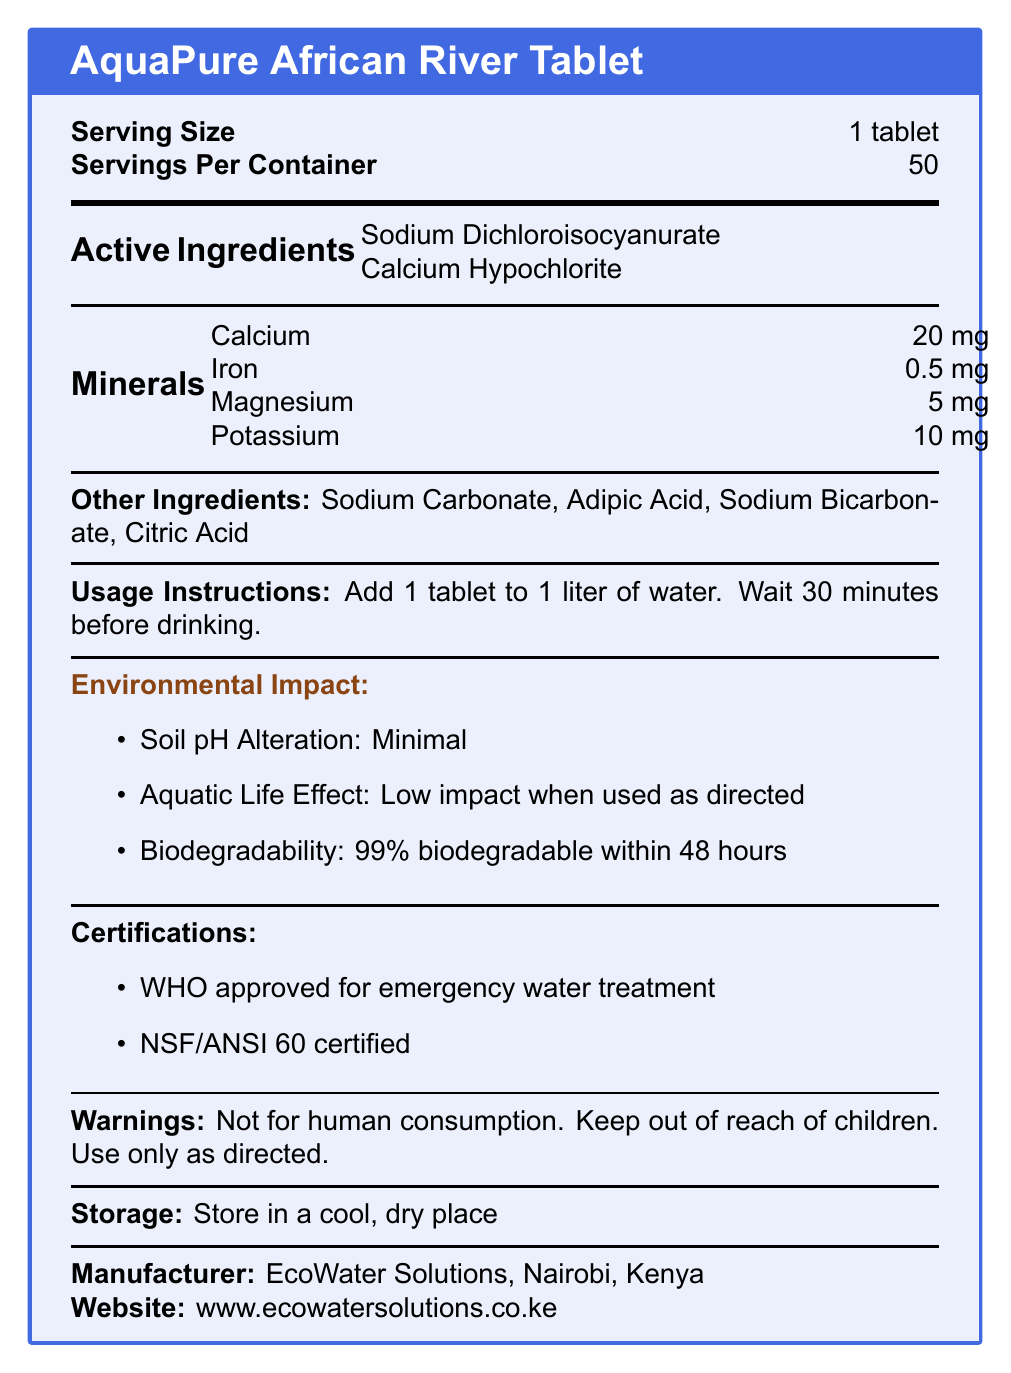Who is the manufacturer of the AquaPure African River Tablet? The document states that the manufacturer is EcoWater Solutions, located in Nairobi, Kenya.
Answer: EcoWater Solutions, Nairobi, Kenya What are the active ingredients in the AquaPure African River Tablet? The active ingredients are given in the section labeled "Active Ingredients" and their amounts are specified as 17 mg for Sodium Dichloroisocyanurate and 8 mg for Calcium Hypochlorite.
Answer: Sodium Dichloroisocyanurate (17 mg) and Calcium Hypochlorite (8 mg) How many servings are in one container of AquaPure African River Tablets? The document specifies that there are 50 servings per container.
Answer: 50 What mineral content is provided by the AquaPure African River Tablet? The mineral content is detailed under the "Minerals" section and includes the amount of each mineral and its daily value percentage.
Answer: Calcium (20 mg, 2%), Iron (0.5 mg, 3%), Magnesium (5 mg, 1%), Potassium (10 mg, <1%) What is the recommended storage condition for the AquaPure African River Tablet? The document advises storing the tablets in a cool, dry place.
Answer: Store in a cool, dry place How long should you wait after adding the tablet to water before drinking? The usage instructions state to wait 30 minutes after adding the tablet to water before consuming it.
Answer: 30 minutes Which of the following is NOT an ingredient in the AquaPure African River Tablet? A. Adipic Acid B. Citric Acid C. Sodium Hypochlorite D. Sodium Bicarbonate The list of other ingredients includes Adipic Acid, Citric Acid, and Sodium Bicarbonate but not Sodium Hypochlorite.
Answer: C. Sodium Hypochlorite What is the daily value percentage of Iron per tablet? A. 1% B. 2% C. 3% D. <1% The document states that each tablet contains 0.5 mg of Iron, which amounts to 3% of the daily value.
Answer: C. 3% Is the AquaPure African River Tablet biodegradable? The document specifies that the tablet is 99% biodegradable within 48 hours.
Answer: Yes What certifications does the AquaPure African River Tablet hold? The certifications listed are WHO approval for emergency water treatment and NSF/ANSI 60 certification.
Answer: WHO approved for emergency water treatment, NSF/ANSI 60 certified Does the AquaPure African River Tablet affect aquatic life when used as directed? The document mentions that the effect on aquatic life is low when used as directed.
Answer: Low impact Can the AquaPure African River Tablet be used for human consumption? The warnings section clearly states that it is not for human consumption.
Answer: No Describe the main idea of the document The main idea is to inform users about the nutritional and functional aspects of the AquaPure African River Tablet, its use for water purification, and related safety and environmental considerations.
Answer: The document provides detailed information about the AquaPure African River Tablet, including its serving size, active and other ingredients, mineral content, usage instructions, environmental impact, certifications, storage recommendations, manufacturer information, and warnings. The tablet is designed to purify water from African rivers and is approved for use in emergency water treatment situations. What is the effect of the AquaPure African River Tablet on soil pH? The document states that the alteration to soil pH when using the tablet is minimal.
Answer: Minimal Where should you go to know more information about the AquaPure African River Tablet? The document provides the website www.ecowatersolutions.co.ke for more information.
Answer: www.ecowatersolutions.co.ke What is the long-term health impact of using this tablet? The document does not provide information about any long-term health impacts of using the tablet.
Answer: Not enough information 